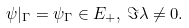<formula> <loc_0><loc_0><loc_500><loc_500>\psi | _ { \Gamma } = \psi _ { \Gamma } \in E _ { + } , \, \Im \lambda \neq 0 .</formula> 